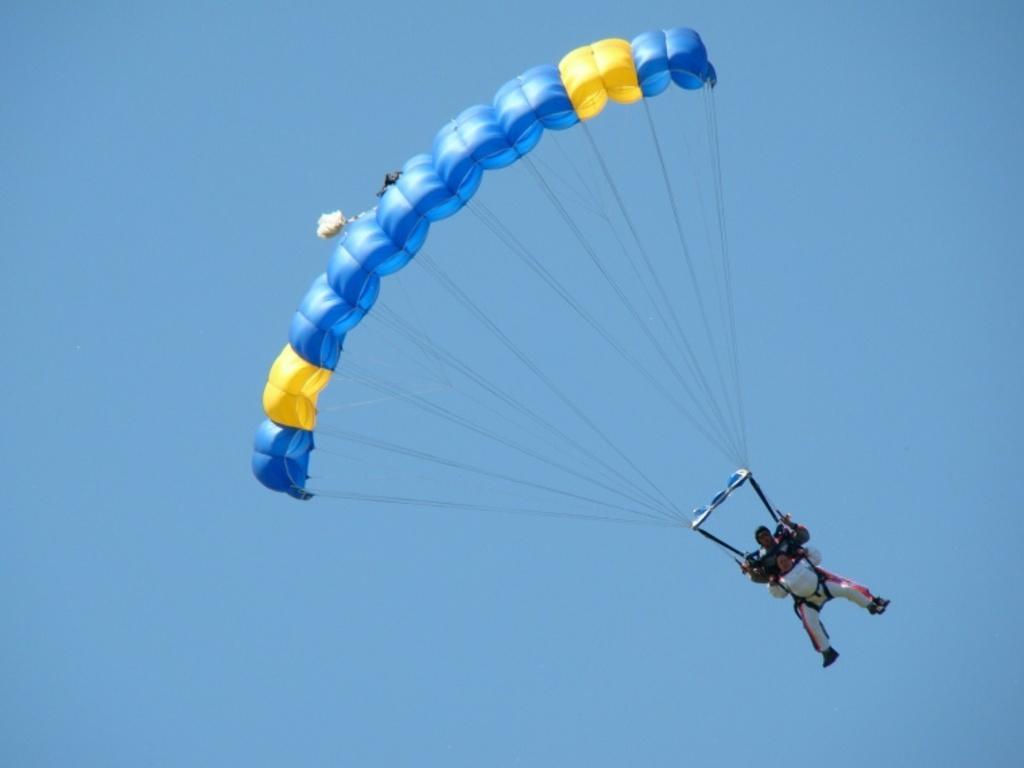In one or two sentences, can you explain what this image depicts? In this image I can see a person flying in the air along with the parachute which is in blue and yellow colors. In the background, I can see the sky in blue color. 